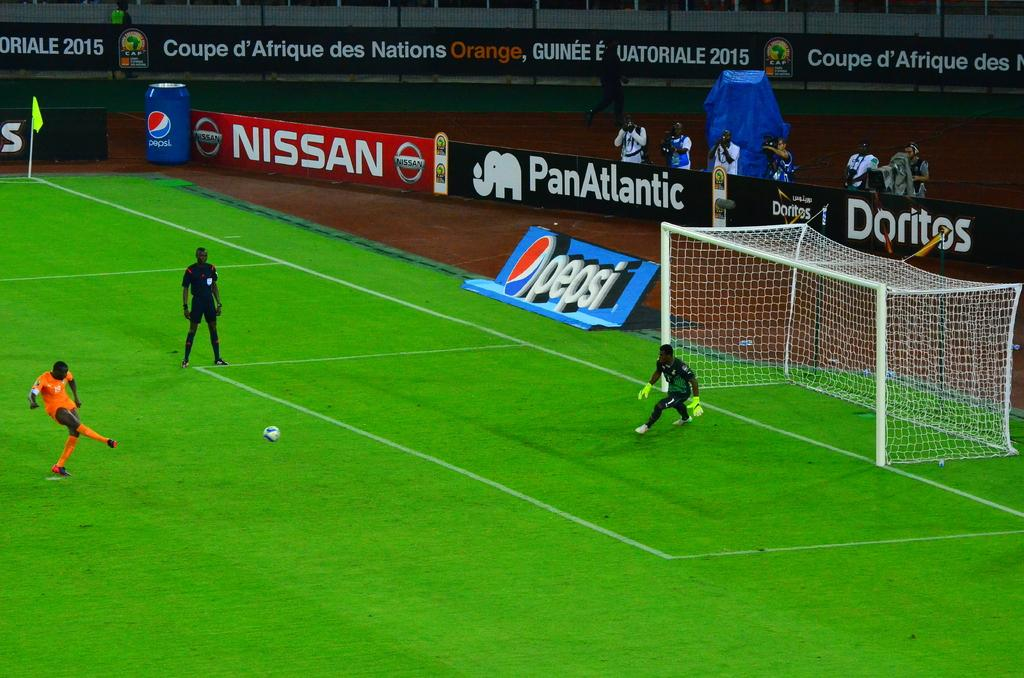<image>
Relay a brief, clear account of the picture shown. a player trying to score a goal in a soccer game on a field sponsored by pepsi 